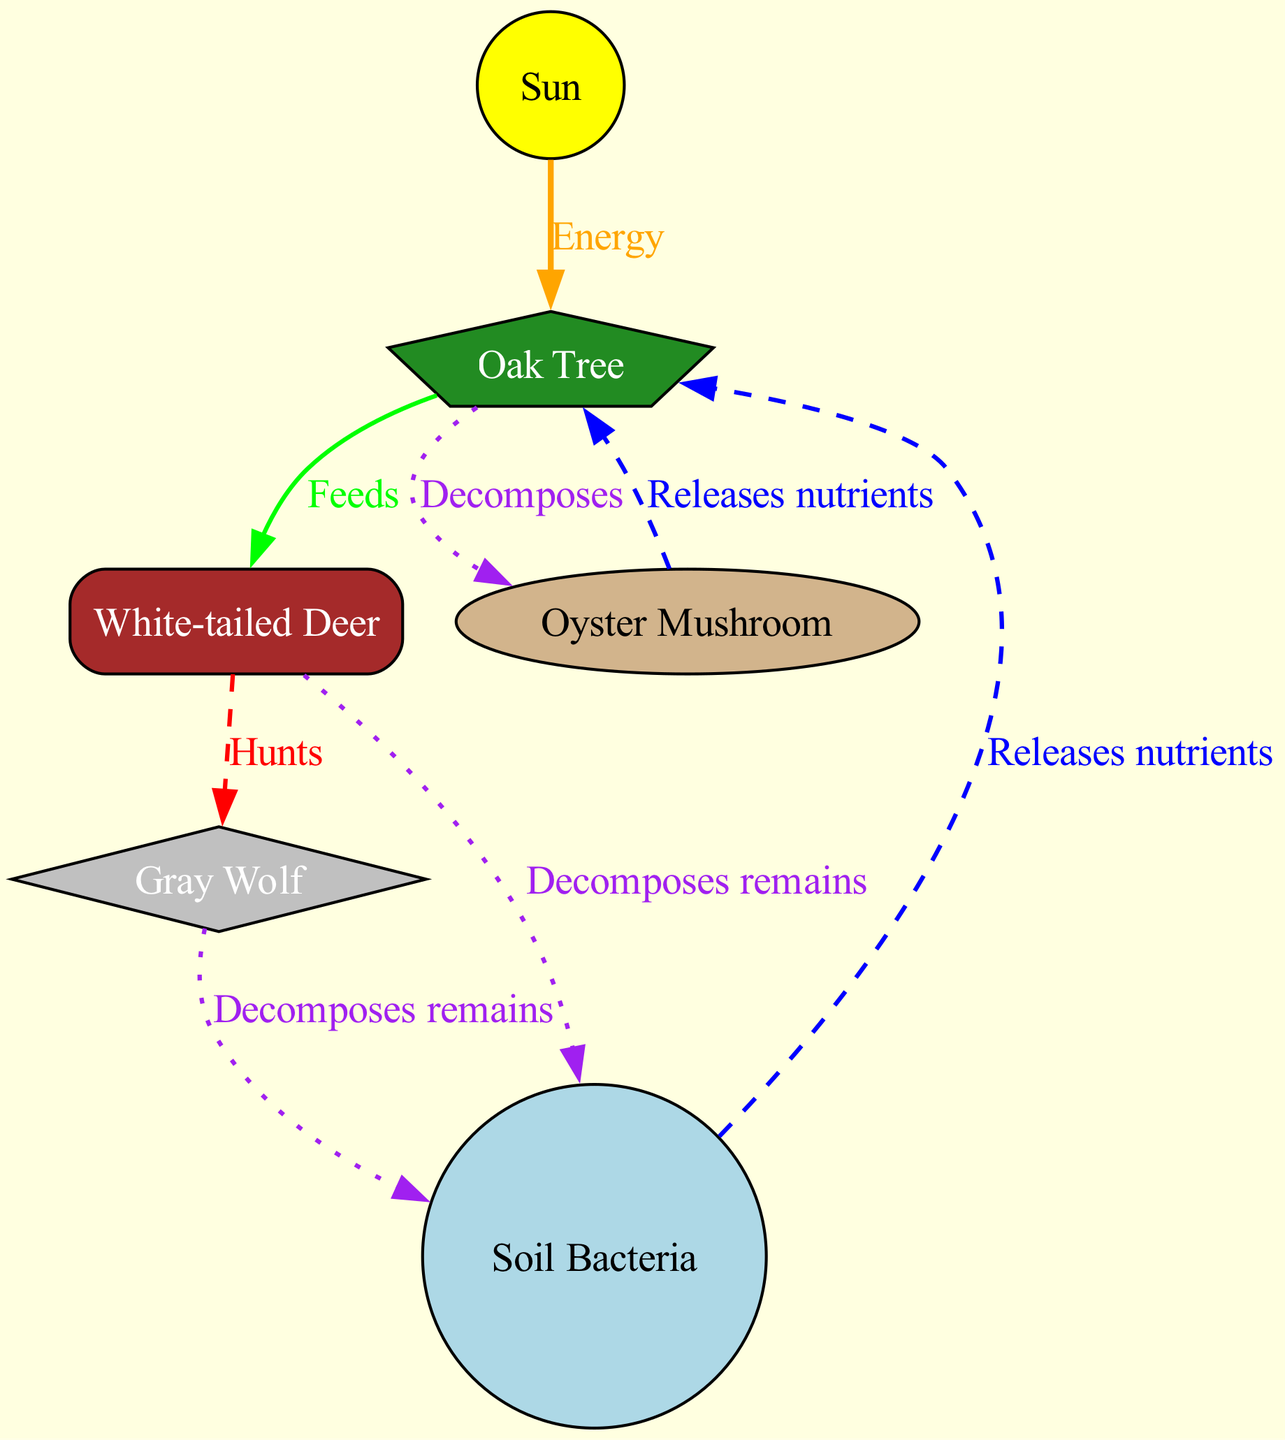What is the total number of nodes in the diagram? The diagram contains nodes representing different elements in the food web. I count the nodes: Sun, Oak Tree, White-tailed Deer, Gray Wolf, Oyster Mushroom, and Soil Bacteria. This totals to 6 nodes.
Answer: 6 Which node is the primary source of energy? The diagram shows that the Sun provides energy to the Oak Tree, which indicates that the Sun is the primary source of energy in this food web.
Answer: Sun How many dead ends exist in the food web? A dead end in the food web occurs where a consumer does not have any predators or further connections. The only instances where remains are decomposed are by bacteria or mushrooms, leading to nutrients but having no further connections. Therefore, there are two dead ends counted through both decomposing processes.
Answer: 2 What does the Oak Tree release back into the environment? The diagram indicates the Oak Tree has connections to both Soil Bacteria and Oyster Mushroom, both showing arrows labeled "Releases nutrients". Thus, it releases nutrients into the environment through these connections.
Answer: Nutrients From which node does the Gray Wolf derive its energy? The Gray Wolf hunts the White-tailed Deer as specified by the edge labeled "Hunts" shown in the diagram. This indicates that the Wolf derives its energy primarily from the Deer.
Answer: White-tailed Deer What role do the Soil Bacteria play in the food web? Soil Bacteria decompose the remains of both Deer and Wolf, returning nutrients to the Oak Tree as shown in the diagram, denoted by arrows labeled "Decomposes remains" and "Releases nutrients". Thus, they play a crucial role in nutrient cycling in the ecosystem.
Answer: Decomposers Which two nodes interact with the Oak Tree through decomposition? The diagram shows that the Oyster Mushroom and the remains of the Deer and Wolf interact with the Oak Tree through the edges that denote decomposition and nutrient release. Hence, the decomposing interactions involve the Mushroom and the remains from both the Deer and Wolf, illustrating their interconnectedness.
Answer: Oyster Mushroom and Soil Bacteria How does energy transfer from the Sun to the Deer? The Sun transfers energy to the Oak Tree first, illustrated by the edge labeled "Energy". The Oak Tree then feeds the White-tailed Deer, making a two-step process where energy is transferred from the Sun to the Deer. Therefore, energy flows Sun → Oak Tree → Deer.
Answer: Sun to Oak Tree to Deer 